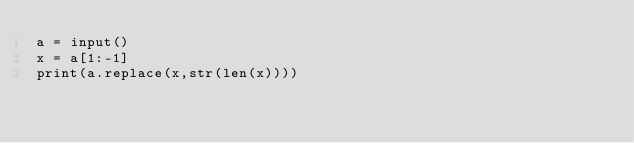Convert code to text. <code><loc_0><loc_0><loc_500><loc_500><_Python_>a = input()
x = a[1:-1]
print(a.replace(x,str(len(x))))</code> 